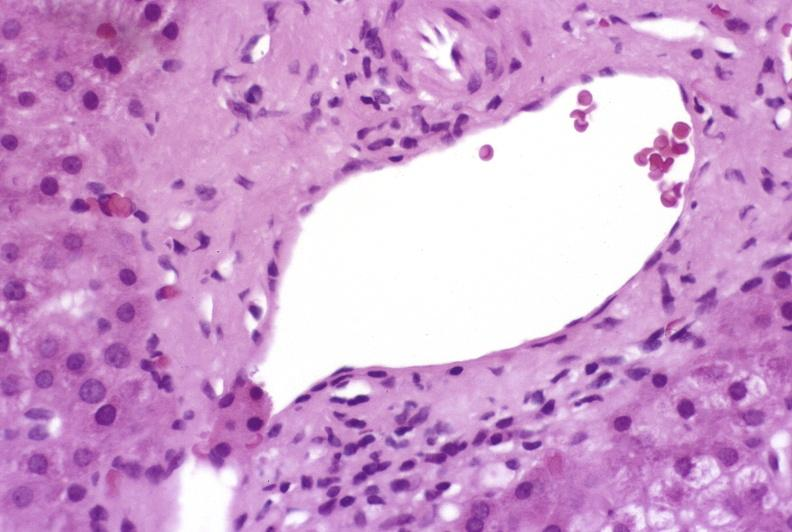does this image show mild-to-moderate acute rejection?
Answer the question using a single word or phrase. Yes 